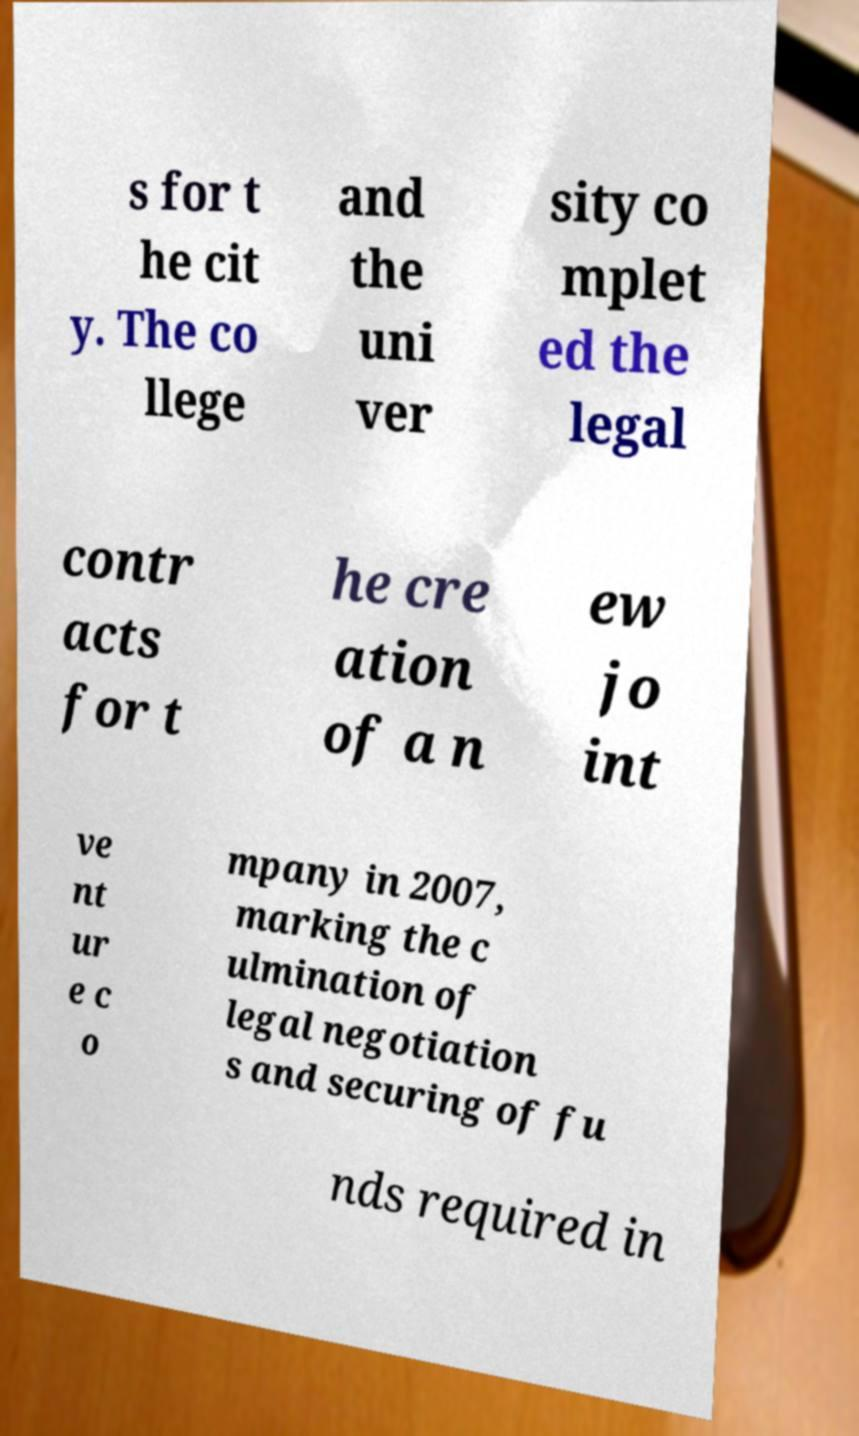Can you accurately transcribe the text from the provided image for me? s for t he cit y. The co llege and the uni ver sity co mplet ed the legal contr acts for t he cre ation of a n ew jo int ve nt ur e c o mpany in 2007, marking the c ulmination of legal negotiation s and securing of fu nds required in 